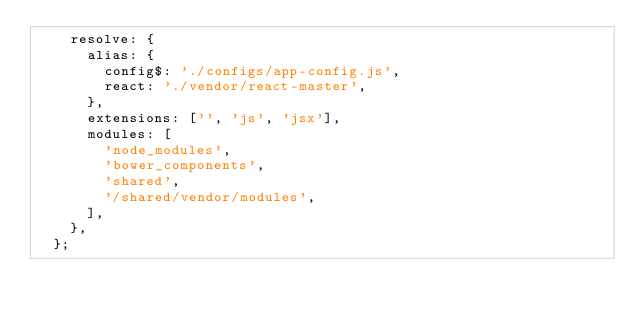<code> <loc_0><loc_0><loc_500><loc_500><_JavaScript_>    resolve: {
      alias: {
        config$: './configs/app-config.js',
        react: './vendor/react-master',
      },
      extensions: ['', 'js', 'jsx'],
      modules: [
        'node_modules',
        'bower_components',
        'shared',
        '/shared/vendor/modules',
      ],
    },
  };</code> 